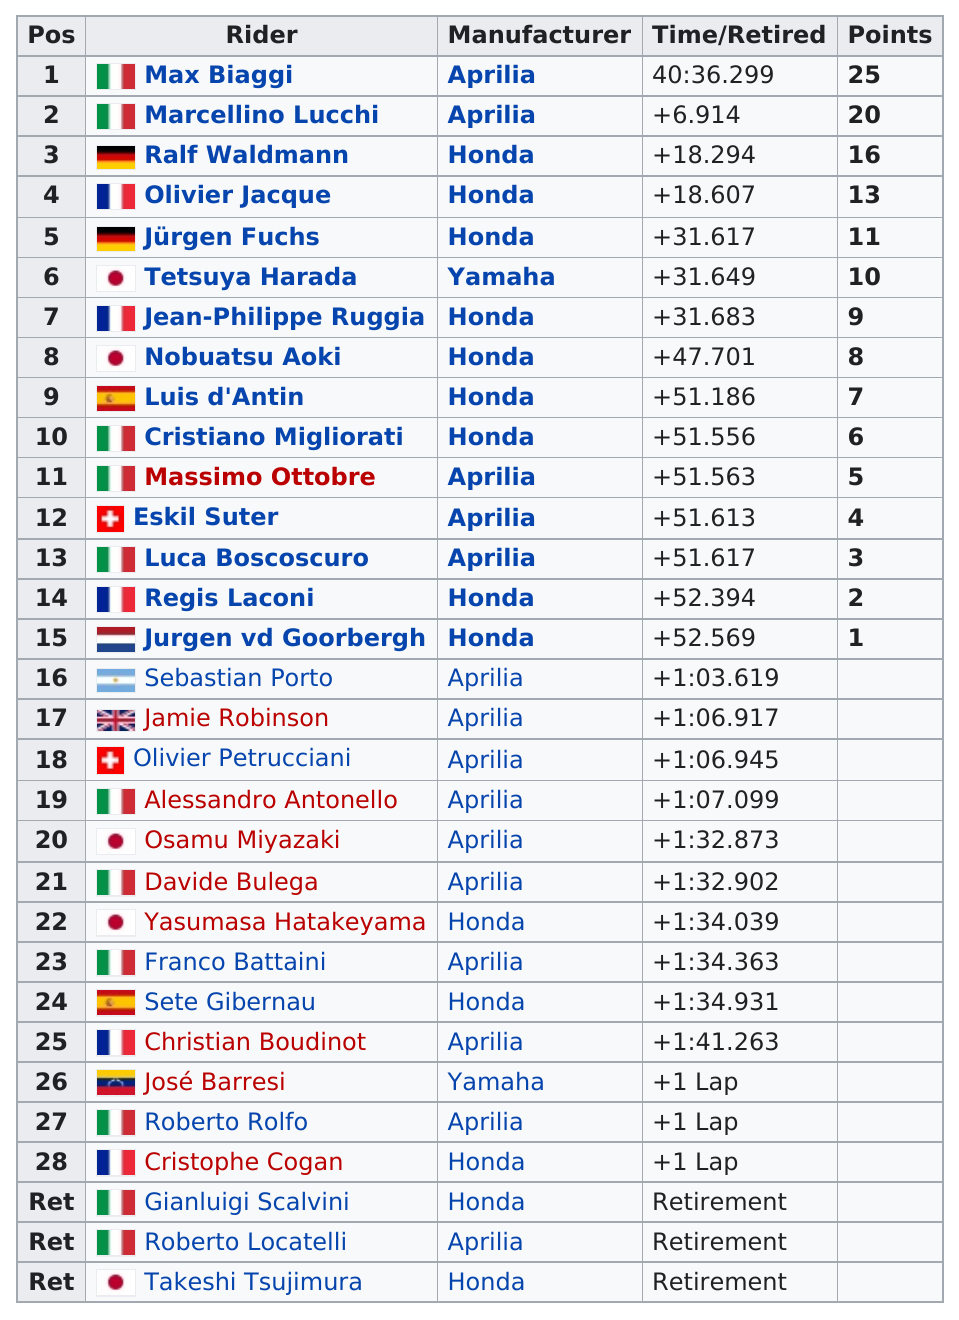Highlight a few significant elements in this photo. Of the Italian riders who placed in the top 10, there were 3. Out of the riders in the top 15, 9 were riding a Honda. Marcellino Lucchi's and Max Biaggi's points differ in number, with Lucchi having five points and Biaggi having an unknown number of points. Takeshi Tsujimura was the last rider in the 250cc class. Italy had the most riders who earned points, making it the country with the most riders in that category. 